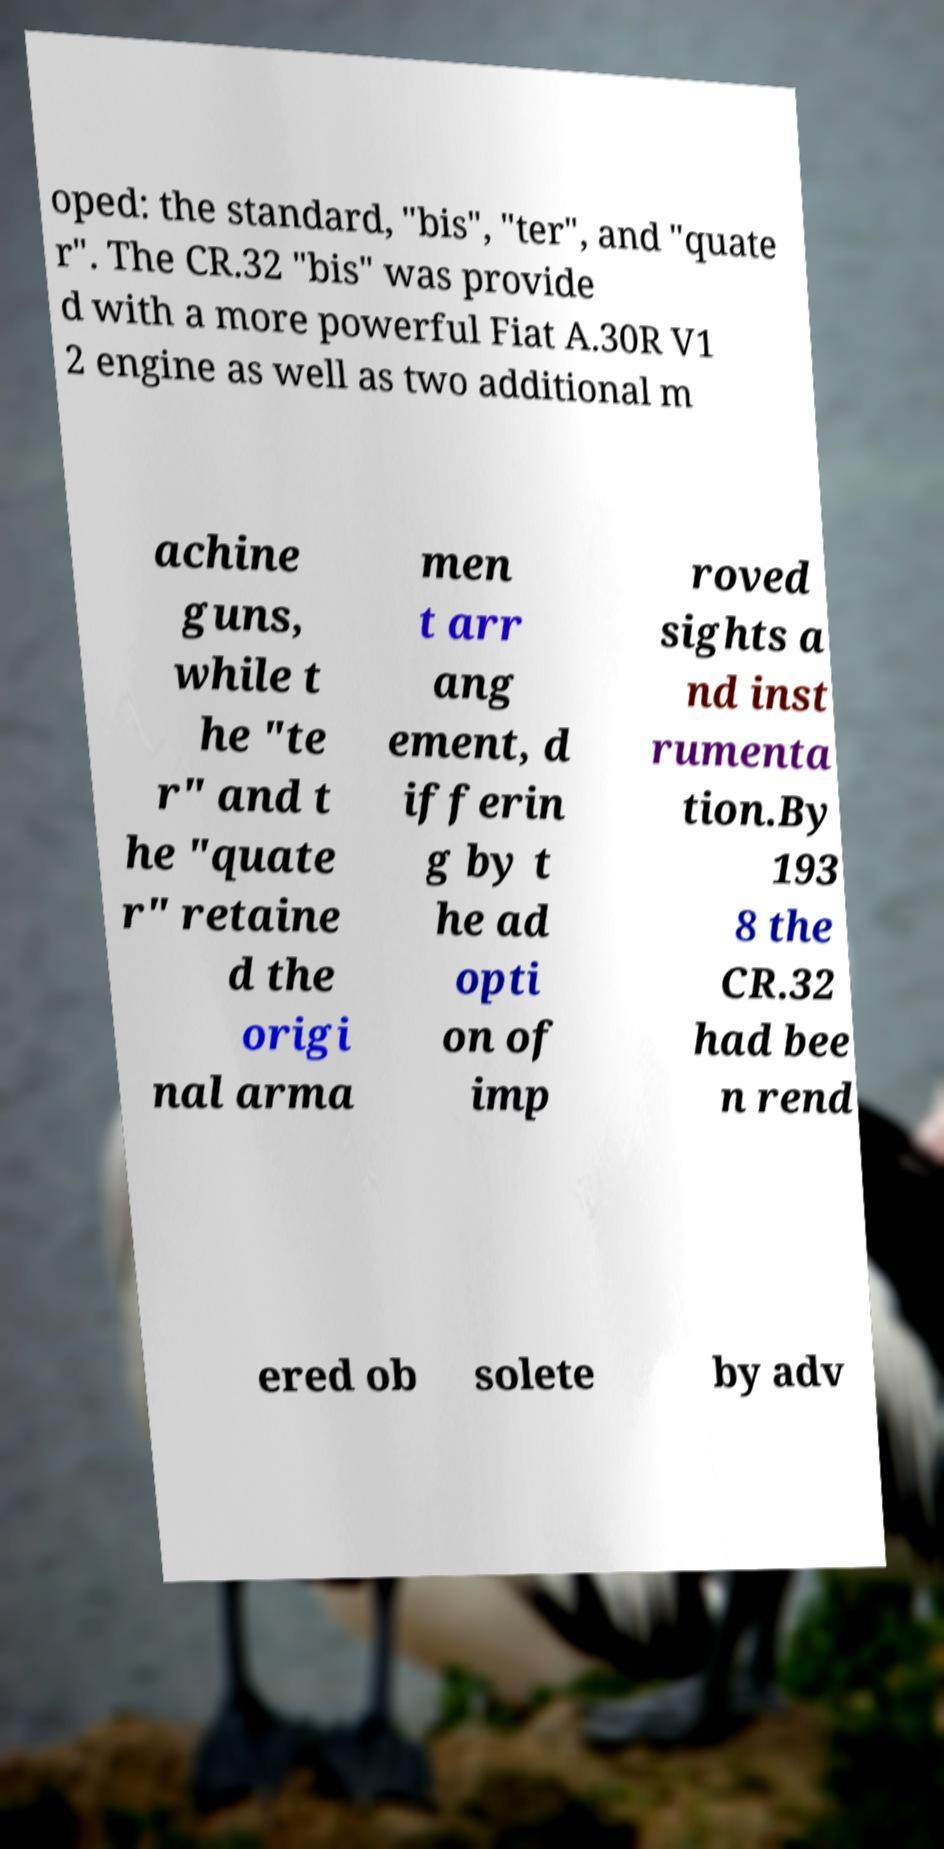What messages or text are displayed in this image? I need them in a readable, typed format. oped: the standard, "bis", "ter", and "quate r". The CR.32 "bis" was provide d with a more powerful Fiat A.30R V1 2 engine as well as two additional m achine guns, while t he "te r" and t he "quate r" retaine d the origi nal arma men t arr ang ement, d ifferin g by t he ad opti on of imp roved sights a nd inst rumenta tion.By 193 8 the CR.32 had bee n rend ered ob solete by adv 